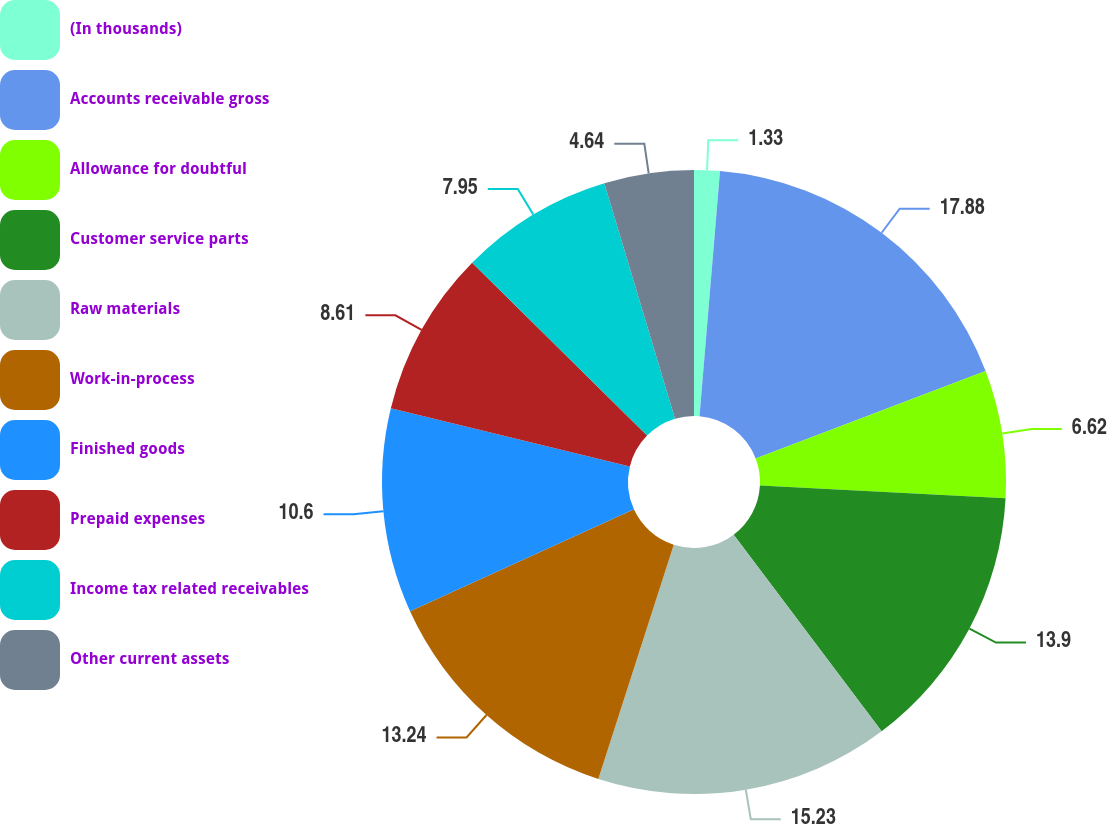Convert chart to OTSL. <chart><loc_0><loc_0><loc_500><loc_500><pie_chart><fcel>(In thousands)<fcel>Accounts receivable gross<fcel>Allowance for doubtful<fcel>Customer service parts<fcel>Raw materials<fcel>Work-in-process<fcel>Finished goods<fcel>Prepaid expenses<fcel>Income tax related receivables<fcel>Other current assets<nl><fcel>1.33%<fcel>17.88%<fcel>6.62%<fcel>13.9%<fcel>15.23%<fcel>13.24%<fcel>10.6%<fcel>8.61%<fcel>7.95%<fcel>4.64%<nl></chart> 